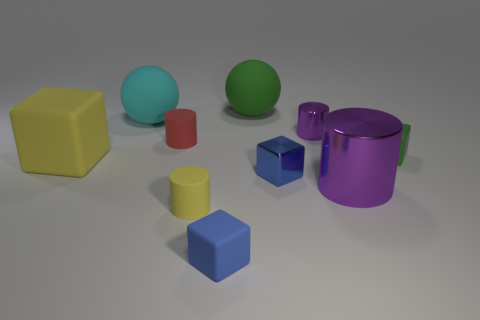Is there a tiny green thing that is on the left side of the purple metal cylinder in front of the blue object that is on the right side of the big green sphere?
Give a very brief answer. No. Are any large gray metallic cylinders visible?
Offer a very short reply. No. Are there more blue rubber blocks to the right of the green matte cube than tiny blue metallic things in front of the blue metal block?
Ensure brevity in your answer.  No. There is a red thing that is the same material as the green cube; what size is it?
Your answer should be compact. Small. There is a purple cylinder in front of the tiny matte cylinder that is behind the yellow object behind the small yellow matte cylinder; what size is it?
Offer a very short reply. Large. There is a small rubber object right of the tiny purple metallic cylinder; what color is it?
Make the answer very short. Green. Are there more large shiny cylinders that are behind the big cyan rubber ball than big blue rubber objects?
Keep it short and to the point. No. There is a yellow object on the right side of the big block; does it have the same shape as the small blue shiny thing?
Offer a terse response. No. How many red things are small matte cubes or tiny rubber cylinders?
Your answer should be compact. 1. Is the number of tiny blue cubes greater than the number of big brown objects?
Your response must be concise. Yes. 